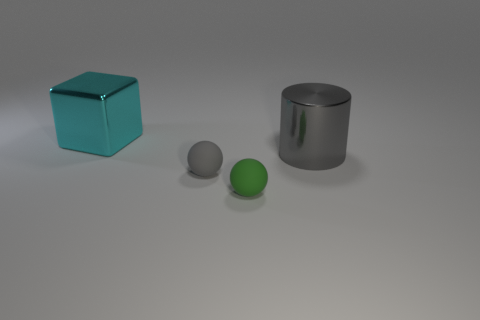Add 3 green spheres. How many objects exist? 7 Subtract all blocks. How many objects are left? 3 Subtract 0 brown cylinders. How many objects are left? 4 Subtract all tiny blue cylinders. Subtract all metallic things. How many objects are left? 2 Add 2 big cyan cubes. How many big cyan cubes are left? 3 Add 1 gray shiny objects. How many gray shiny objects exist? 2 